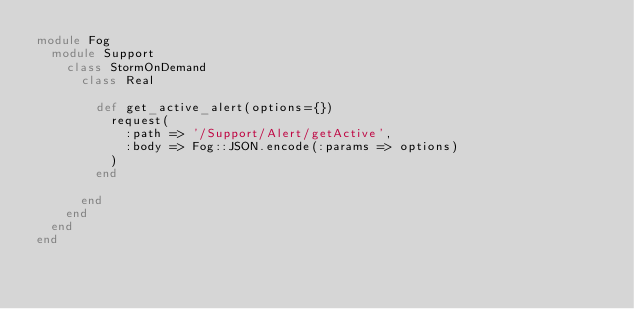<code> <loc_0><loc_0><loc_500><loc_500><_Ruby_>module Fog
  module Support
    class StormOnDemand
      class Real

        def get_active_alert(options={})
          request(
            :path => '/Support/Alert/getActive',
            :body => Fog::JSON.encode(:params => options)
          )
        end

      end
    end
  end
end
</code> 